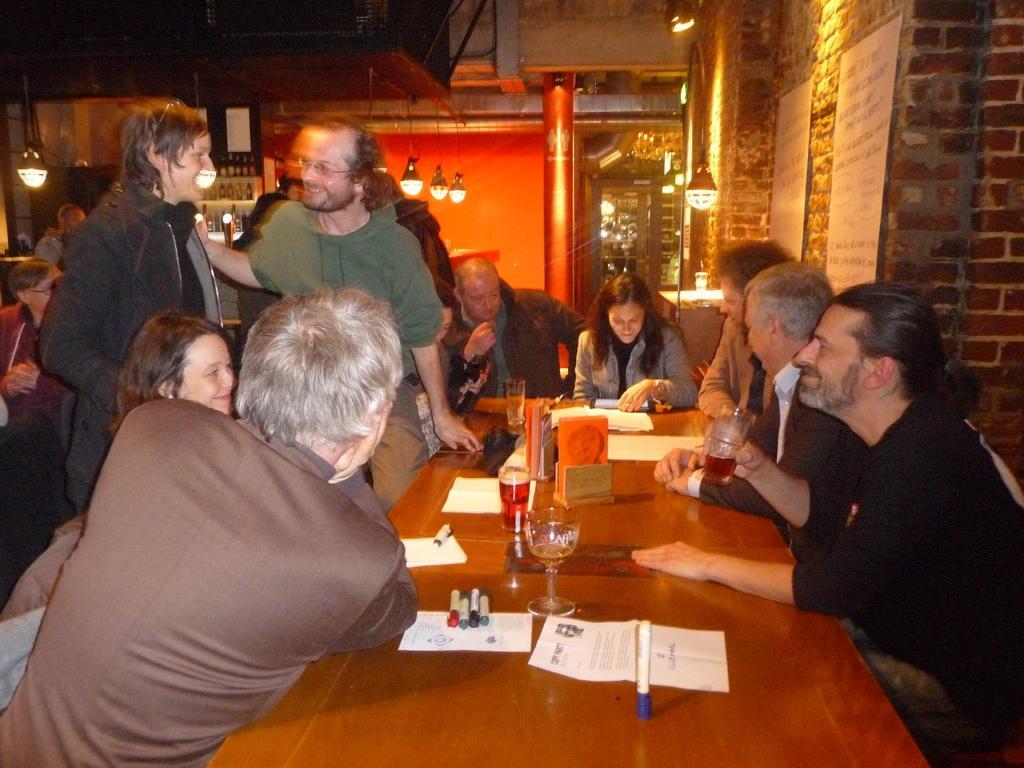Could you give a brief overview of what you see in this image? In this image we can see a group of persons are sitting on the table, and in front here is the table and glasses and papers and books and some objects on it, and here are the two persons standing, and at back here is the wall made of bricks, and here are the lights. 